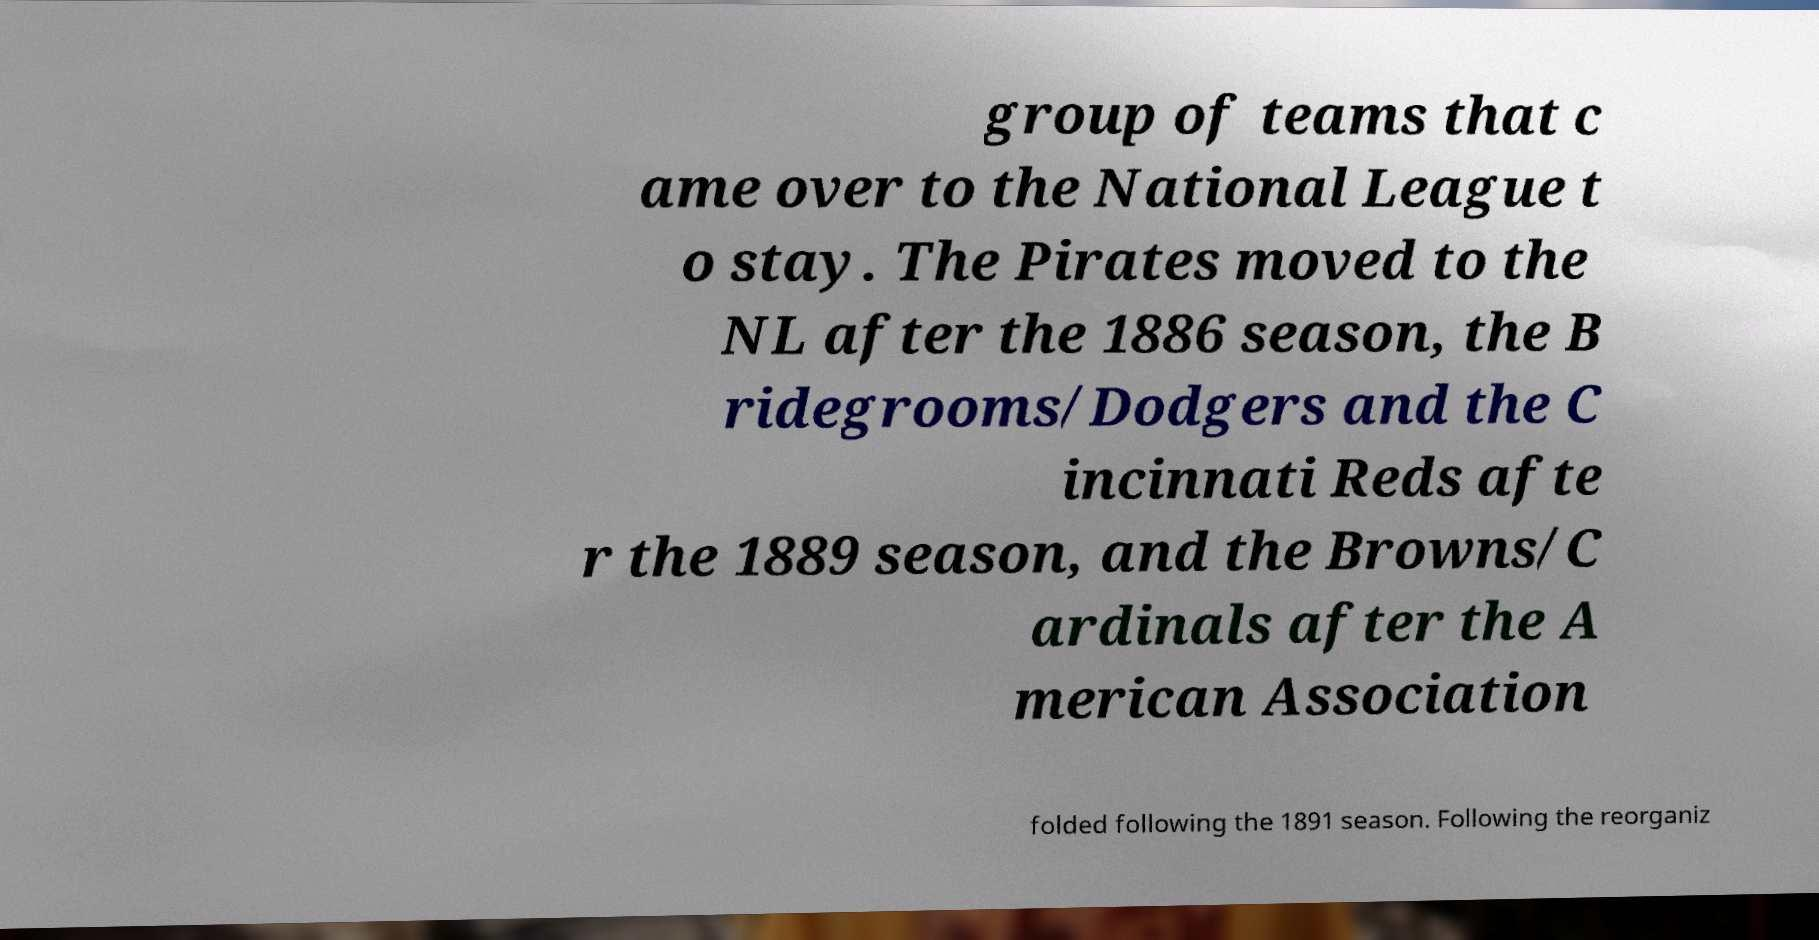For documentation purposes, I need the text within this image transcribed. Could you provide that? group of teams that c ame over to the National League t o stay. The Pirates moved to the NL after the 1886 season, the B ridegrooms/Dodgers and the C incinnati Reds afte r the 1889 season, and the Browns/C ardinals after the A merican Association folded following the 1891 season. Following the reorganiz 